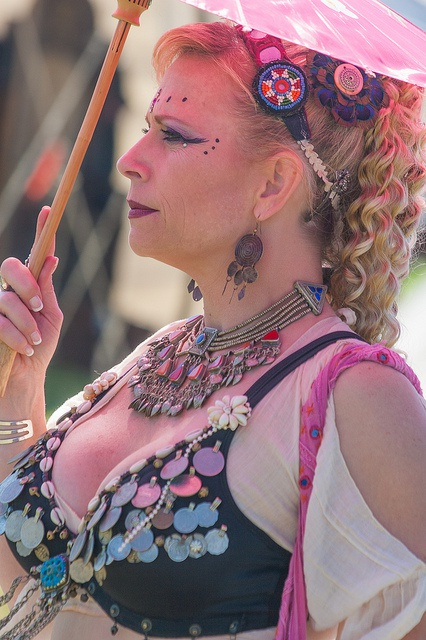Describe the objects in this image and their specific colors. I can see people in lightgray, brown, darkgray, black, and gray tones and umbrella in lightgray, pink, and salmon tones in this image. 